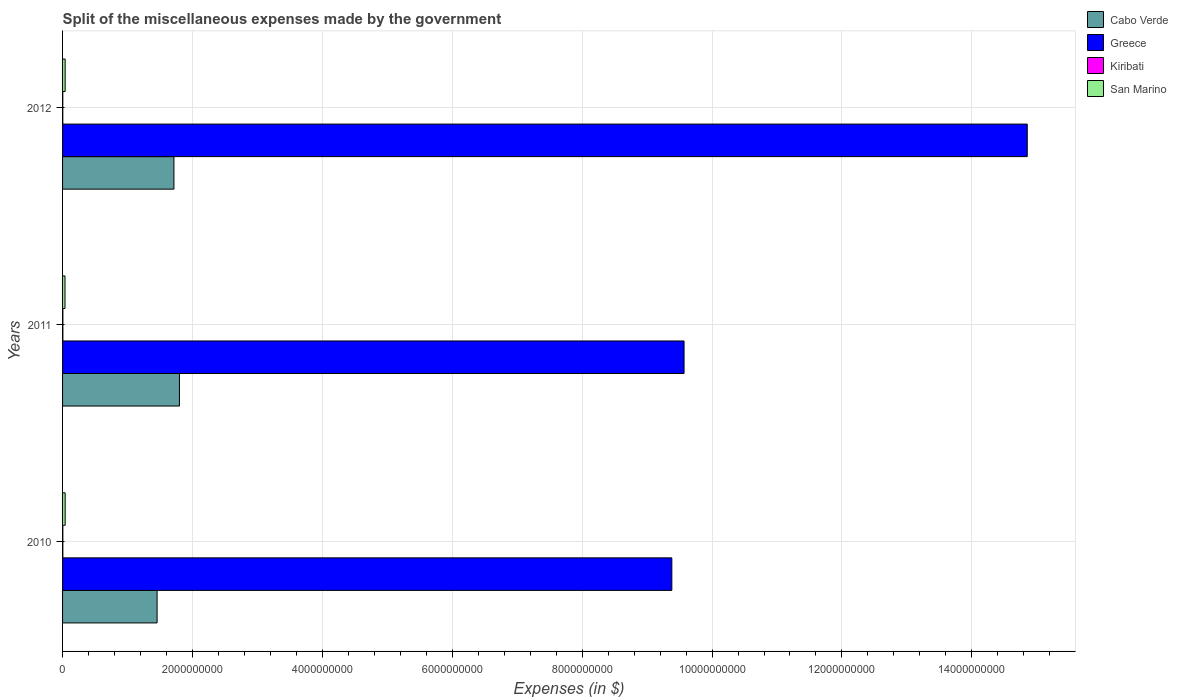How many different coloured bars are there?
Provide a succinct answer. 4. How many groups of bars are there?
Provide a succinct answer. 3. How many bars are there on the 2nd tick from the top?
Give a very brief answer. 4. In how many cases, is the number of bars for a given year not equal to the number of legend labels?
Your answer should be very brief. 0. What is the miscellaneous expenses made by the government in San Marino in 2010?
Make the answer very short. 4.00e+07. Across all years, what is the maximum miscellaneous expenses made by the government in Cabo Verde?
Keep it short and to the point. 1.80e+09. Across all years, what is the minimum miscellaneous expenses made by the government in Greece?
Provide a short and direct response. 9.38e+09. In which year was the miscellaneous expenses made by the government in San Marino minimum?
Your response must be concise. 2011. What is the total miscellaneous expenses made by the government in Cabo Verde in the graph?
Offer a terse response. 4.97e+09. What is the difference between the miscellaneous expenses made by the government in Kiribati in 2010 and that in 2012?
Your answer should be very brief. 6.88e+05. What is the difference between the miscellaneous expenses made by the government in Cabo Verde in 2010 and the miscellaneous expenses made by the government in Greece in 2012?
Keep it short and to the point. -1.34e+1. What is the average miscellaneous expenses made by the government in Cabo Verde per year?
Provide a succinct answer. 1.66e+09. In the year 2011, what is the difference between the miscellaneous expenses made by the government in San Marino and miscellaneous expenses made by the government in Cabo Verde?
Provide a short and direct response. -1.76e+09. What is the ratio of the miscellaneous expenses made by the government in Kiribati in 2010 to that in 2011?
Ensure brevity in your answer.  0.92. What is the difference between the highest and the second highest miscellaneous expenses made by the government in San Marino?
Your answer should be very brief. 1.60e+05. What is the difference between the highest and the lowest miscellaneous expenses made by the government in Kiribati?
Give a very brief answer. 1.05e+06. Is it the case that in every year, the sum of the miscellaneous expenses made by the government in Greece and miscellaneous expenses made by the government in Cabo Verde is greater than the sum of miscellaneous expenses made by the government in Kiribati and miscellaneous expenses made by the government in San Marino?
Keep it short and to the point. Yes. What does the 3rd bar from the top in 2010 represents?
Give a very brief answer. Greece. Is it the case that in every year, the sum of the miscellaneous expenses made by the government in Greece and miscellaneous expenses made by the government in Cabo Verde is greater than the miscellaneous expenses made by the government in Kiribati?
Keep it short and to the point. Yes. How many bars are there?
Provide a short and direct response. 12. How many years are there in the graph?
Provide a succinct answer. 3. Does the graph contain any zero values?
Provide a short and direct response. No. Does the graph contain grids?
Your response must be concise. Yes. How many legend labels are there?
Give a very brief answer. 4. How are the legend labels stacked?
Your answer should be compact. Vertical. What is the title of the graph?
Give a very brief answer. Split of the miscellaneous expenses made by the government. What is the label or title of the X-axis?
Ensure brevity in your answer.  Expenses (in $). What is the Expenses (in $) of Cabo Verde in 2010?
Make the answer very short. 1.46e+09. What is the Expenses (in $) of Greece in 2010?
Provide a succinct answer. 9.38e+09. What is the Expenses (in $) in Kiribati in 2010?
Ensure brevity in your answer.  4.28e+06. What is the Expenses (in $) in San Marino in 2010?
Give a very brief answer. 4.00e+07. What is the Expenses (in $) of Cabo Verde in 2011?
Ensure brevity in your answer.  1.80e+09. What is the Expenses (in $) of Greece in 2011?
Offer a terse response. 9.57e+09. What is the Expenses (in $) of Kiribati in 2011?
Ensure brevity in your answer.  4.65e+06. What is the Expenses (in $) of San Marino in 2011?
Give a very brief answer. 3.76e+07. What is the Expenses (in $) of Cabo Verde in 2012?
Offer a terse response. 1.71e+09. What is the Expenses (in $) in Greece in 2012?
Your response must be concise. 1.49e+1. What is the Expenses (in $) in Kiribati in 2012?
Provide a succinct answer. 3.59e+06. What is the Expenses (in $) of San Marino in 2012?
Your answer should be compact. 3.99e+07. Across all years, what is the maximum Expenses (in $) of Cabo Verde?
Ensure brevity in your answer.  1.80e+09. Across all years, what is the maximum Expenses (in $) of Greece?
Your answer should be very brief. 1.49e+1. Across all years, what is the maximum Expenses (in $) in Kiribati?
Your answer should be very brief. 4.65e+06. Across all years, what is the maximum Expenses (in $) of San Marino?
Your response must be concise. 4.00e+07. Across all years, what is the minimum Expenses (in $) in Cabo Verde?
Offer a very short reply. 1.46e+09. Across all years, what is the minimum Expenses (in $) in Greece?
Provide a succinct answer. 9.38e+09. Across all years, what is the minimum Expenses (in $) of Kiribati?
Offer a terse response. 3.59e+06. Across all years, what is the minimum Expenses (in $) of San Marino?
Provide a succinct answer. 3.76e+07. What is the total Expenses (in $) in Cabo Verde in the graph?
Give a very brief answer. 4.97e+09. What is the total Expenses (in $) in Greece in the graph?
Your answer should be very brief. 3.38e+1. What is the total Expenses (in $) in Kiribati in the graph?
Your response must be concise. 1.25e+07. What is the total Expenses (in $) of San Marino in the graph?
Your answer should be compact. 1.17e+08. What is the difference between the Expenses (in $) of Cabo Verde in 2010 and that in 2011?
Provide a succinct answer. -3.44e+08. What is the difference between the Expenses (in $) of Greece in 2010 and that in 2011?
Ensure brevity in your answer.  -1.88e+08. What is the difference between the Expenses (in $) in Kiribati in 2010 and that in 2011?
Provide a short and direct response. -3.65e+05. What is the difference between the Expenses (in $) of San Marino in 2010 and that in 2011?
Your response must be concise. 2.44e+06. What is the difference between the Expenses (in $) in Cabo Verde in 2010 and that in 2012?
Your answer should be compact. -2.59e+08. What is the difference between the Expenses (in $) in Greece in 2010 and that in 2012?
Give a very brief answer. -5.47e+09. What is the difference between the Expenses (in $) of Kiribati in 2010 and that in 2012?
Your answer should be very brief. 6.88e+05. What is the difference between the Expenses (in $) in San Marino in 2010 and that in 2012?
Give a very brief answer. 1.60e+05. What is the difference between the Expenses (in $) in Cabo Verde in 2011 and that in 2012?
Keep it short and to the point. 8.47e+07. What is the difference between the Expenses (in $) in Greece in 2011 and that in 2012?
Offer a very short reply. -5.28e+09. What is the difference between the Expenses (in $) in Kiribati in 2011 and that in 2012?
Offer a terse response. 1.05e+06. What is the difference between the Expenses (in $) of San Marino in 2011 and that in 2012?
Offer a very short reply. -2.28e+06. What is the difference between the Expenses (in $) of Cabo Verde in 2010 and the Expenses (in $) of Greece in 2011?
Your answer should be compact. -8.11e+09. What is the difference between the Expenses (in $) in Cabo Verde in 2010 and the Expenses (in $) in Kiribati in 2011?
Provide a succinct answer. 1.45e+09. What is the difference between the Expenses (in $) in Cabo Verde in 2010 and the Expenses (in $) in San Marino in 2011?
Provide a succinct answer. 1.42e+09. What is the difference between the Expenses (in $) of Greece in 2010 and the Expenses (in $) of Kiribati in 2011?
Provide a short and direct response. 9.38e+09. What is the difference between the Expenses (in $) of Greece in 2010 and the Expenses (in $) of San Marino in 2011?
Give a very brief answer. 9.34e+09. What is the difference between the Expenses (in $) in Kiribati in 2010 and the Expenses (in $) in San Marino in 2011?
Provide a short and direct response. -3.33e+07. What is the difference between the Expenses (in $) of Cabo Verde in 2010 and the Expenses (in $) of Greece in 2012?
Provide a succinct answer. -1.34e+1. What is the difference between the Expenses (in $) in Cabo Verde in 2010 and the Expenses (in $) in Kiribati in 2012?
Offer a very short reply. 1.45e+09. What is the difference between the Expenses (in $) in Cabo Verde in 2010 and the Expenses (in $) in San Marino in 2012?
Your answer should be compact. 1.42e+09. What is the difference between the Expenses (in $) in Greece in 2010 and the Expenses (in $) in Kiribati in 2012?
Your answer should be very brief. 9.38e+09. What is the difference between the Expenses (in $) of Greece in 2010 and the Expenses (in $) of San Marino in 2012?
Offer a terse response. 9.34e+09. What is the difference between the Expenses (in $) of Kiribati in 2010 and the Expenses (in $) of San Marino in 2012?
Give a very brief answer. -3.56e+07. What is the difference between the Expenses (in $) in Cabo Verde in 2011 and the Expenses (in $) in Greece in 2012?
Provide a short and direct response. -1.31e+1. What is the difference between the Expenses (in $) in Cabo Verde in 2011 and the Expenses (in $) in Kiribati in 2012?
Your answer should be very brief. 1.80e+09. What is the difference between the Expenses (in $) of Cabo Verde in 2011 and the Expenses (in $) of San Marino in 2012?
Your answer should be very brief. 1.76e+09. What is the difference between the Expenses (in $) in Greece in 2011 and the Expenses (in $) in Kiribati in 2012?
Your answer should be compact. 9.57e+09. What is the difference between the Expenses (in $) of Greece in 2011 and the Expenses (in $) of San Marino in 2012?
Keep it short and to the point. 9.53e+09. What is the difference between the Expenses (in $) in Kiribati in 2011 and the Expenses (in $) in San Marino in 2012?
Your response must be concise. -3.52e+07. What is the average Expenses (in $) of Cabo Verde per year?
Ensure brevity in your answer.  1.66e+09. What is the average Expenses (in $) in Greece per year?
Your answer should be compact. 1.13e+1. What is the average Expenses (in $) in Kiribati per year?
Your answer should be very brief. 4.17e+06. What is the average Expenses (in $) in San Marino per year?
Your answer should be compact. 3.91e+07. In the year 2010, what is the difference between the Expenses (in $) in Cabo Verde and Expenses (in $) in Greece?
Your answer should be very brief. -7.93e+09. In the year 2010, what is the difference between the Expenses (in $) in Cabo Verde and Expenses (in $) in Kiribati?
Your response must be concise. 1.45e+09. In the year 2010, what is the difference between the Expenses (in $) of Cabo Verde and Expenses (in $) of San Marino?
Your response must be concise. 1.42e+09. In the year 2010, what is the difference between the Expenses (in $) of Greece and Expenses (in $) of Kiribati?
Ensure brevity in your answer.  9.38e+09. In the year 2010, what is the difference between the Expenses (in $) in Greece and Expenses (in $) in San Marino?
Keep it short and to the point. 9.34e+09. In the year 2010, what is the difference between the Expenses (in $) of Kiribati and Expenses (in $) of San Marino?
Make the answer very short. -3.57e+07. In the year 2011, what is the difference between the Expenses (in $) of Cabo Verde and Expenses (in $) of Greece?
Your response must be concise. -7.77e+09. In the year 2011, what is the difference between the Expenses (in $) in Cabo Verde and Expenses (in $) in Kiribati?
Your answer should be compact. 1.79e+09. In the year 2011, what is the difference between the Expenses (in $) in Cabo Verde and Expenses (in $) in San Marino?
Your answer should be very brief. 1.76e+09. In the year 2011, what is the difference between the Expenses (in $) of Greece and Expenses (in $) of Kiribati?
Make the answer very short. 9.56e+09. In the year 2011, what is the difference between the Expenses (in $) of Greece and Expenses (in $) of San Marino?
Offer a terse response. 9.53e+09. In the year 2011, what is the difference between the Expenses (in $) of Kiribati and Expenses (in $) of San Marino?
Your response must be concise. -3.29e+07. In the year 2012, what is the difference between the Expenses (in $) in Cabo Verde and Expenses (in $) in Greece?
Your answer should be very brief. -1.31e+1. In the year 2012, what is the difference between the Expenses (in $) of Cabo Verde and Expenses (in $) of Kiribati?
Provide a succinct answer. 1.71e+09. In the year 2012, what is the difference between the Expenses (in $) of Cabo Verde and Expenses (in $) of San Marino?
Your answer should be compact. 1.68e+09. In the year 2012, what is the difference between the Expenses (in $) in Greece and Expenses (in $) in Kiribati?
Your answer should be compact. 1.48e+1. In the year 2012, what is the difference between the Expenses (in $) in Greece and Expenses (in $) in San Marino?
Make the answer very short. 1.48e+1. In the year 2012, what is the difference between the Expenses (in $) of Kiribati and Expenses (in $) of San Marino?
Keep it short and to the point. -3.63e+07. What is the ratio of the Expenses (in $) of Cabo Verde in 2010 to that in 2011?
Ensure brevity in your answer.  0.81. What is the ratio of the Expenses (in $) in Greece in 2010 to that in 2011?
Provide a succinct answer. 0.98. What is the ratio of the Expenses (in $) in Kiribati in 2010 to that in 2011?
Provide a short and direct response. 0.92. What is the ratio of the Expenses (in $) in San Marino in 2010 to that in 2011?
Ensure brevity in your answer.  1.06. What is the ratio of the Expenses (in $) of Cabo Verde in 2010 to that in 2012?
Your answer should be compact. 0.85. What is the ratio of the Expenses (in $) in Greece in 2010 to that in 2012?
Give a very brief answer. 0.63. What is the ratio of the Expenses (in $) in Kiribati in 2010 to that in 2012?
Your answer should be very brief. 1.19. What is the ratio of the Expenses (in $) of San Marino in 2010 to that in 2012?
Your answer should be very brief. 1. What is the ratio of the Expenses (in $) in Cabo Verde in 2011 to that in 2012?
Give a very brief answer. 1.05. What is the ratio of the Expenses (in $) in Greece in 2011 to that in 2012?
Your answer should be compact. 0.64. What is the ratio of the Expenses (in $) of Kiribati in 2011 to that in 2012?
Offer a very short reply. 1.29. What is the ratio of the Expenses (in $) in San Marino in 2011 to that in 2012?
Ensure brevity in your answer.  0.94. What is the difference between the highest and the second highest Expenses (in $) of Cabo Verde?
Make the answer very short. 8.47e+07. What is the difference between the highest and the second highest Expenses (in $) in Greece?
Keep it short and to the point. 5.28e+09. What is the difference between the highest and the second highest Expenses (in $) of Kiribati?
Your answer should be very brief. 3.65e+05. What is the difference between the highest and the second highest Expenses (in $) in San Marino?
Give a very brief answer. 1.60e+05. What is the difference between the highest and the lowest Expenses (in $) of Cabo Verde?
Offer a very short reply. 3.44e+08. What is the difference between the highest and the lowest Expenses (in $) of Greece?
Provide a short and direct response. 5.47e+09. What is the difference between the highest and the lowest Expenses (in $) of Kiribati?
Make the answer very short. 1.05e+06. What is the difference between the highest and the lowest Expenses (in $) of San Marino?
Provide a short and direct response. 2.44e+06. 